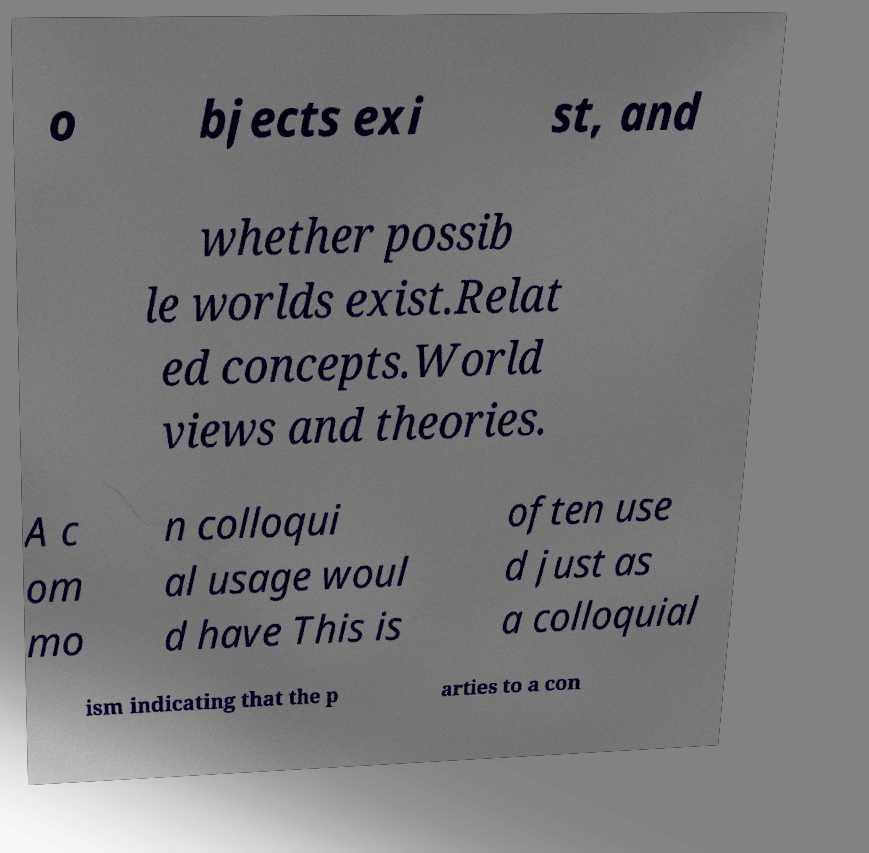Can you accurately transcribe the text from the provided image for me? o bjects exi st, and whether possib le worlds exist.Relat ed concepts.World views and theories. A c om mo n colloqui al usage woul d have This is often use d just as a colloquial ism indicating that the p arties to a con 